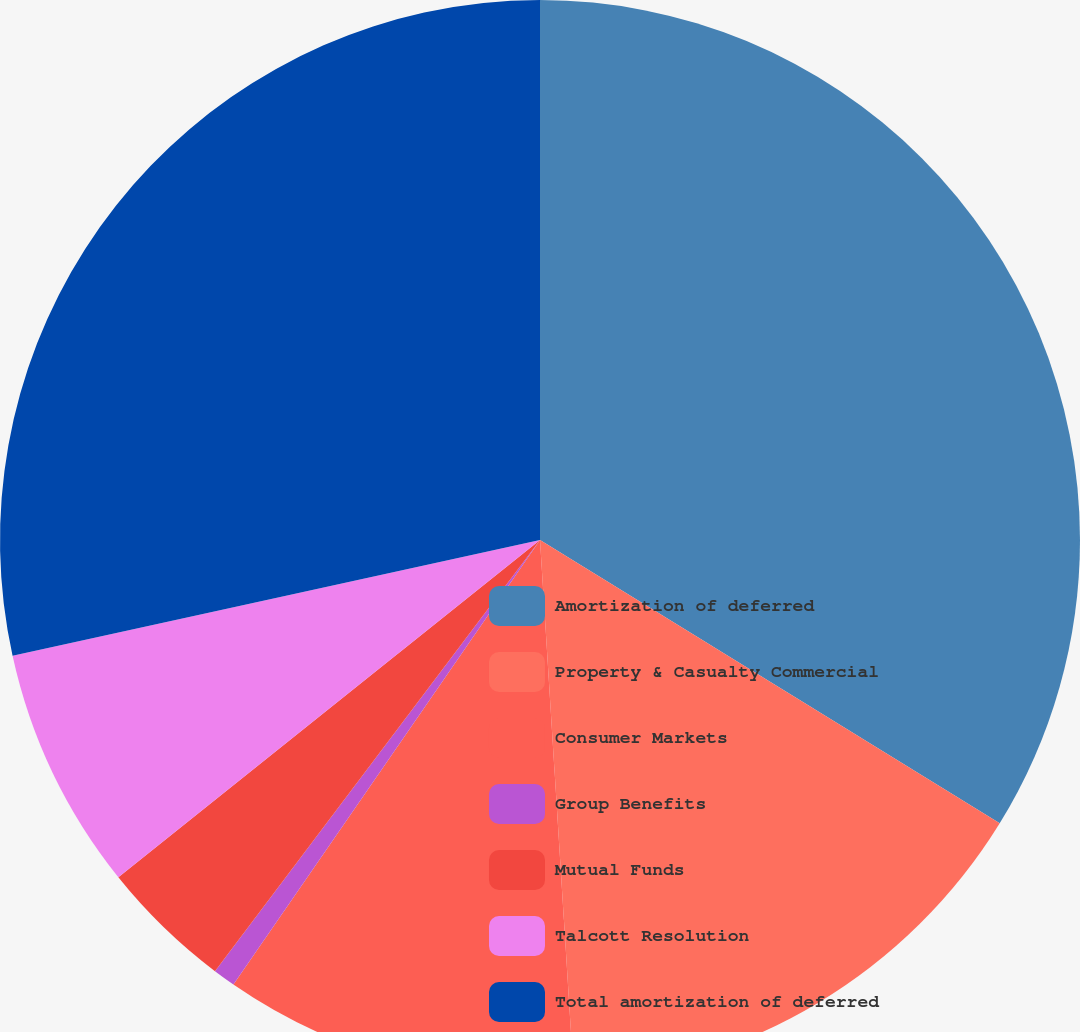<chart> <loc_0><loc_0><loc_500><loc_500><pie_chart><fcel>Amortization of deferred<fcel>Property & Casualty Commercial<fcel>Consumer Markets<fcel>Group Benefits<fcel>Mutual Funds<fcel>Talcott Resolution<fcel>Total amortization of deferred<nl><fcel>33.79%<fcel>15.21%<fcel>10.61%<fcel>0.67%<fcel>3.98%<fcel>7.3%<fcel>28.44%<nl></chart> 